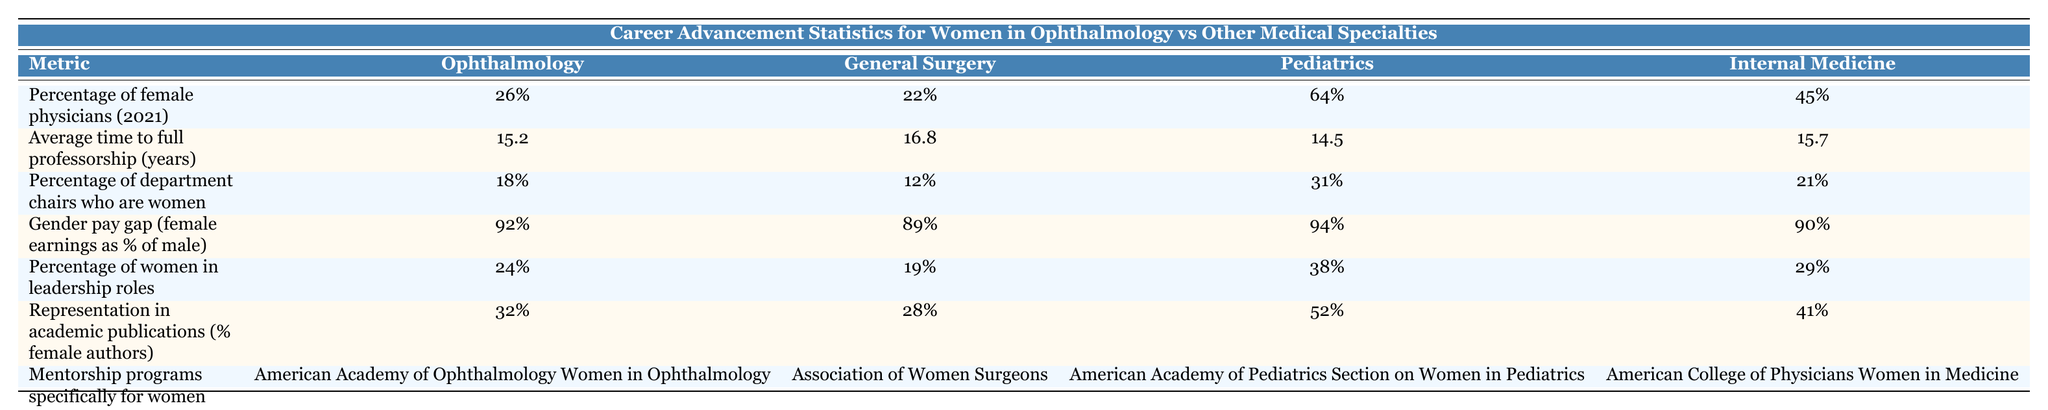What is the percentage of female physicians in ophthalmology? The table indicates that the percentage of female physicians in ophthalmology is listed under the corresponding column, which shows that it is 26%.
Answer: 26% Which specialty has the highest percentage of women in leadership roles? By looking at the column for the percentage of women in leadership roles, pediatrics stands out as having the highest value at 38%.
Answer: 38% What is the gender pay gap in ophthalmology compared to general surgery? In ophthalmology, the gender pay gap is 92%, whereas in general surgery it is 89%. Specifically, 92% in ophthalmology vs 89% in general surgery shows that ophthalmology has a slightly better pay gap for women.
Answer: 92% vs 89% What is the average time to full professorship for women in ophthalmology compared to pediatrics? The average time for women to reach full professorship is 15.2 years in ophthalmology and 14.5 years in pediatrics. By comparing these two values, ophthalmology takes longer by 0.7 years.
Answer: 15.2 years vs 14.5 years Is the percentage of department chairs who are women higher in ophthalmology than in internal medicine? In ophthalmology, 18% of department chairs are women, while in internal medicine it is 21%. Therefore, the percentage in ophthalmology is not higher; it is lower than internal medicine.
Answer: No How much lower is the percentage of female department chairs in ophthalmology compared to pediatrics? The percentage of female department chairs in ophthalmology is 18%, and in pediatrics, it is 31%. The difference is 31% - 18% = 13%. This means that pediatrics has 13% more female department chairs than ophthalmology.
Answer: 13% What is the representation of female authors in academic publications in ophthalmology compared to general surgery? In ophthalmology, the percentage of female authors in academic publications is 32%. In general surgery, it is 28%. This indicates that ophthalmology has a higher representation of female authors by 4%.
Answer: 32% vs 28% Which mentorship program is specifically available for women in ophthalmology? The table lists the American Academy of Ophthalmology Women in Ophthalmology as the mentorship program available specifically for women in that field.
Answer: American Academy of Ophthalmology Women in Ophthalmology Which medical specialty has the lowest representation in academic publications by female authors? Upon reviewing the percentages of female authors in academic publications, general surgery has 28%, which is the lowest when compared to the other specialties listed.
Answer: 28% 